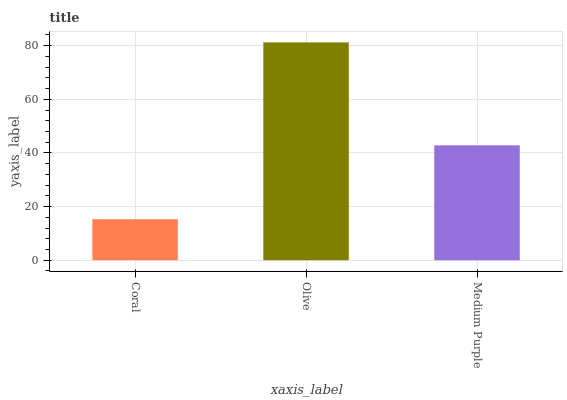Is Coral the minimum?
Answer yes or no. Yes. Is Olive the maximum?
Answer yes or no. Yes. Is Medium Purple the minimum?
Answer yes or no. No. Is Medium Purple the maximum?
Answer yes or no. No. Is Olive greater than Medium Purple?
Answer yes or no. Yes. Is Medium Purple less than Olive?
Answer yes or no. Yes. Is Medium Purple greater than Olive?
Answer yes or no. No. Is Olive less than Medium Purple?
Answer yes or no. No. Is Medium Purple the high median?
Answer yes or no. Yes. Is Medium Purple the low median?
Answer yes or no. Yes. Is Olive the high median?
Answer yes or no. No. Is Coral the low median?
Answer yes or no. No. 